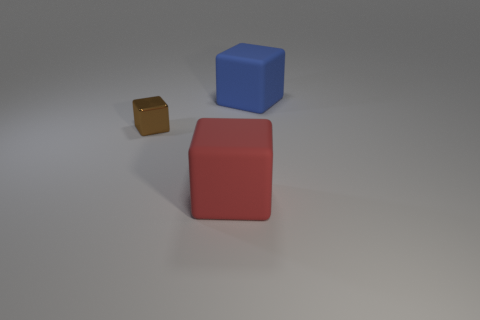Subtract 1 cubes. How many cubes are left? 2 Subtract all big blue rubber cubes. How many cubes are left? 2 Add 3 blue rubber objects. How many objects exist? 6 Add 3 metallic objects. How many metallic objects are left? 4 Add 3 red rubber objects. How many red rubber objects exist? 4 Subtract 0 green spheres. How many objects are left? 3 Subtract all big green rubber cubes. Subtract all brown shiny blocks. How many objects are left? 2 